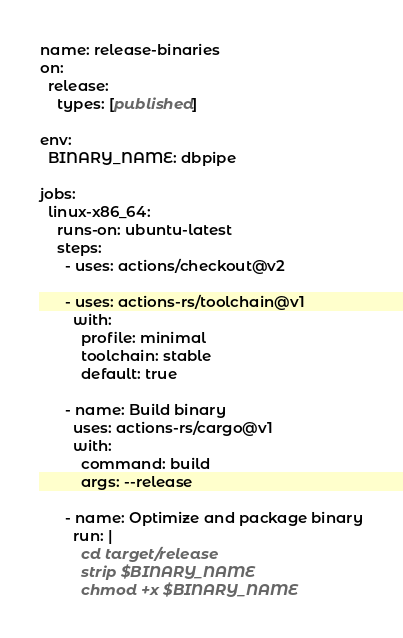<code> <loc_0><loc_0><loc_500><loc_500><_YAML_>name: release-binaries
on:
  release:
    types: [published]

env:
  BINARY_NAME: dbpipe

jobs:
  linux-x86_64:
    runs-on: ubuntu-latest
    steps:
      - uses: actions/checkout@v2

      - uses: actions-rs/toolchain@v1
        with:
          profile: minimal
          toolchain: stable
          default: true

      - name: Build binary
        uses: actions-rs/cargo@v1
        with:
          command: build
          args: --release

      - name: Optimize and package binary
        run: |
          cd target/release
          strip $BINARY_NAME
          chmod +x $BINARY_NAME</code> 